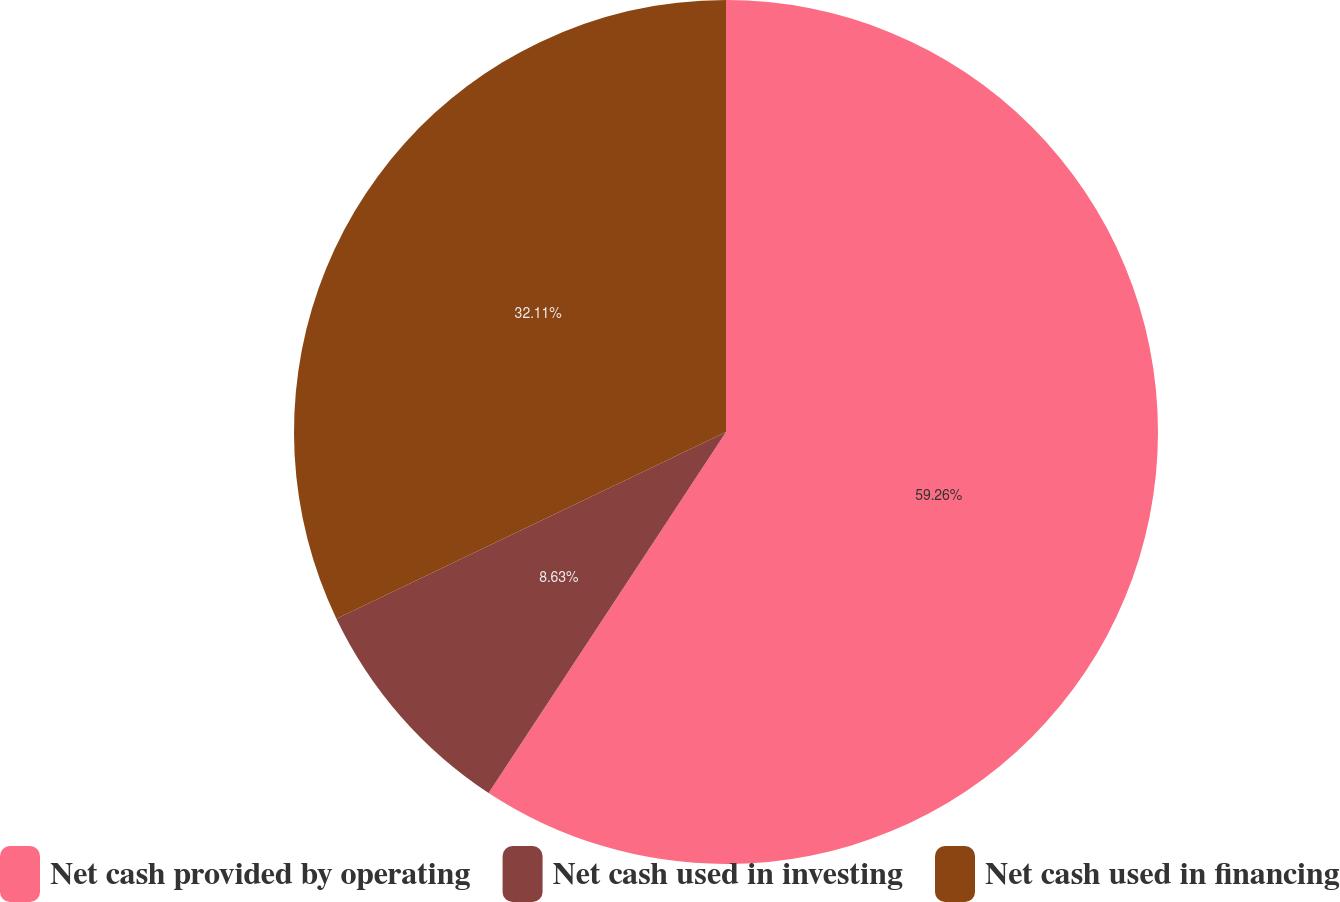Convert chart to OTSL. <chart><loc_0><loc_0><loc_500><loc_500><pie_chart><fcel>Net cash provided by operating<fcel>Net cash used in investing<fcel>Net cash used in financing<nl><fcel>59.26%<fcel>8.63%<fcel>32.11%<nl></chart> 